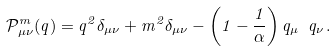<formula> <loc_0><loc_0><loc_500><loc_500>\mathcal { P } _ { \mu \nu } ^ { m } ( q ) = q ^ { 2 } \delta _ { \mu \nu } + m ^ { 2 } \delta _ { \mu \nu } - \left ( 1 - \frac { 1 } { \alpha } \right ) q _ { \mu } { \ } q _ { \nu } \, .</formula> 